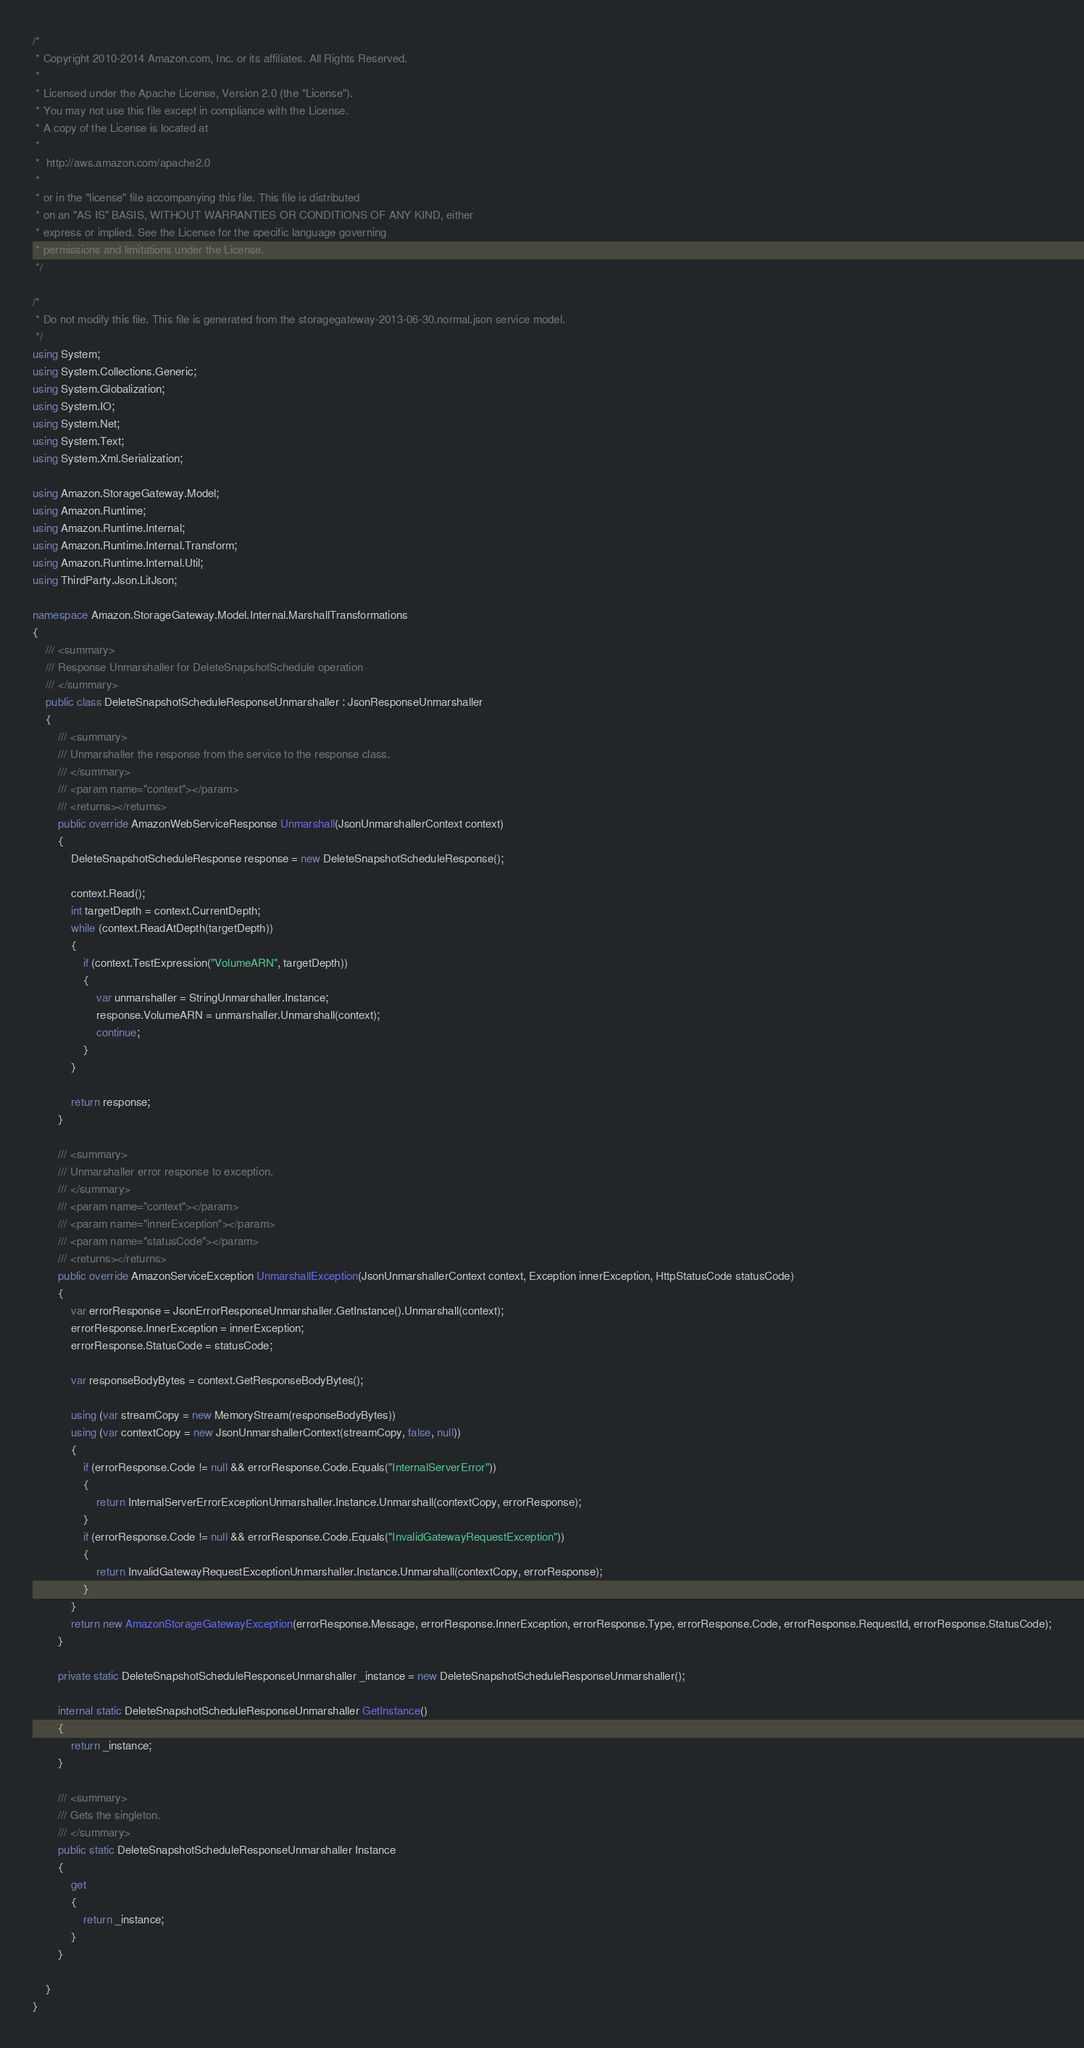<code> <loc_0><loc_0><loc_500><loc_500><_C#_>/*
 * Copyright 2010-2014 Amazon.com, Inc. or its affiliates. All Rights Reserved.
 * 
 * Licensed under the Apache License, Version 2.0 (the "License").
 * You may not use this file except in compliance with the License.
 * A copy of the License is located at
 * 
 *  http://aws.amazon.com/apache2.0
 * 
 * or in the "license" file accompanying this file. This file is distributed
 * on an "AS IS" BASIS, WITHOUT WARRANTIES OR CONDITIONS OF ANY KIND, either
 * express or implied. See the License for the specific language governing
 * permissions and limitations under the License.
 */

/*
 * Do not modify this file. This file is generated from the storagegateway-2013-06-30.normal.json service model.
 */
using System;
using System.Collections.Generic;
using System.Globalization;
using System.IO;
using System.Net;
using System.Text;
using System.Xml.Serialization;

using Amazon.StorageGateway.Model;
using Amazon.Runtime;
using Amazon.Runtime.Internal;
using Amazon.Runtime.Internal.Transform;
using Amazon.Runtime.Internal.Util;
using ThirdParty.Json.LitJson;

namespace Amazon.StorageGateway.Model.Internal.MarshallTransformations
{
    /// <summary>
    /// Response Unmarshaller for DeleteSnapshotSchedule operation
    /// </summary>  
    public class DeleteSnapshotScheduleResponseUnmarshaller : JsonResponseUnmarshaller
    {
        /// <summary>
        /// Unmarshaller the response from the service to the response class.
        /// </summary>  
        /// <param name="context"></param>
        /// <returns></returns>
        public override AmazonWebServiceResponse Unmarshall(JsonUnmarshallerContext context)
        {
            DeleteSnapshotScheduleResponse response = new DeleteSnapshotScheduleResponse();

            context.Read();
            int targetDepth = context.CurrentDepth;
            while (context.ReadAtDepth(targetDepth))
            {
                if (context.TestExpression("VolumeARN", targetDepth))
                {
                    var unmarshaller = StringUnmarshaller.Instance;
                    response.VolumeARN = unmarshaller.Unmarshall(context);
                    continue;
                }
            }

            return response;
        }

        /// <summary>
        /// Unmarshaller error response to exception.
        /// </summary>  
        /// <param name="context"></param>
        /// <param name="innerException"></param>
        /// <param name="statusCode"></param>
        /// <returns></returns>
        public override AmazonServiceException UnmarshallException(JsonUnmarshallerContext context, Exception innerException, HttpStatusCode statusCode)
        {
            var errorResponse = JsonErrorResponseUnmarshaller.GetInstance().Unmarshall(context);
            errorResponse.InnerException = innerException;
            errorResponse.StatusCode = statusCode;

            var responseBodyBytes = context.GetResponseBodyBytes();

            using (var streamCopy = new MemoryStream(responseBodyBytes))
            using (var contextCopy = new JsonUnmarshallerContext(streamCopy, false, null))
            {
                if (errorResponse.Code != null && errorResponse.Code.Equals("InternalServerError"))
                {
                    return InternalServerErrorExceptionUnmarshaller.Instance.Unmarshall(contextCopy, errorResponse);
                }
                if (errorResponse.Code != null && errorResponse.Code.Equals("InvalidGatewayRequestException"))
                {
                    return InvalidGatewayRequestExceptionUnmarshaller.Instance.Unmarshall(contextCopy, errorResponse);
                }
            }
            return new AmazonStorageGatewayException(errorResponse.Message, errorResponse.InnerException, errorResponse.Type, errorResponse.Code, errorResponse.RequestId, errorResponse.StatusCode);
        }

        private static DeleteSnapshotScheduleResponseUnmarshaller _instance = new DeleteSnapshotScheduleResponseUnmarshaller();        

        internal static DeleteSnapshotScheduleResponseUnmarshaller GetInstance()
        {
            return _instance;
        }

        /// <summary>
        /// Gets the singleton.
        /// </summary>  
        public static DeleteSnapshotScheduleResponseUnmarshaller Instance
        {
            get
            {
                return _instance;
            }
        }

    }
}</code> 